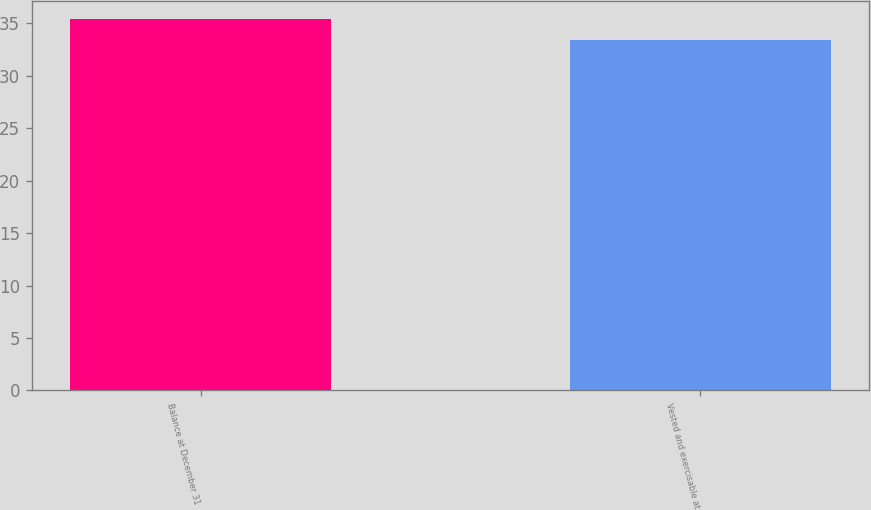<chart> <loc_0><loc_0><loc_500><loc_500><bar_chart><fcel>Balance at December 31<fcel>Vested and exercisable at<nl><fcel>35.39<fcel>33.4<nl></chart> 